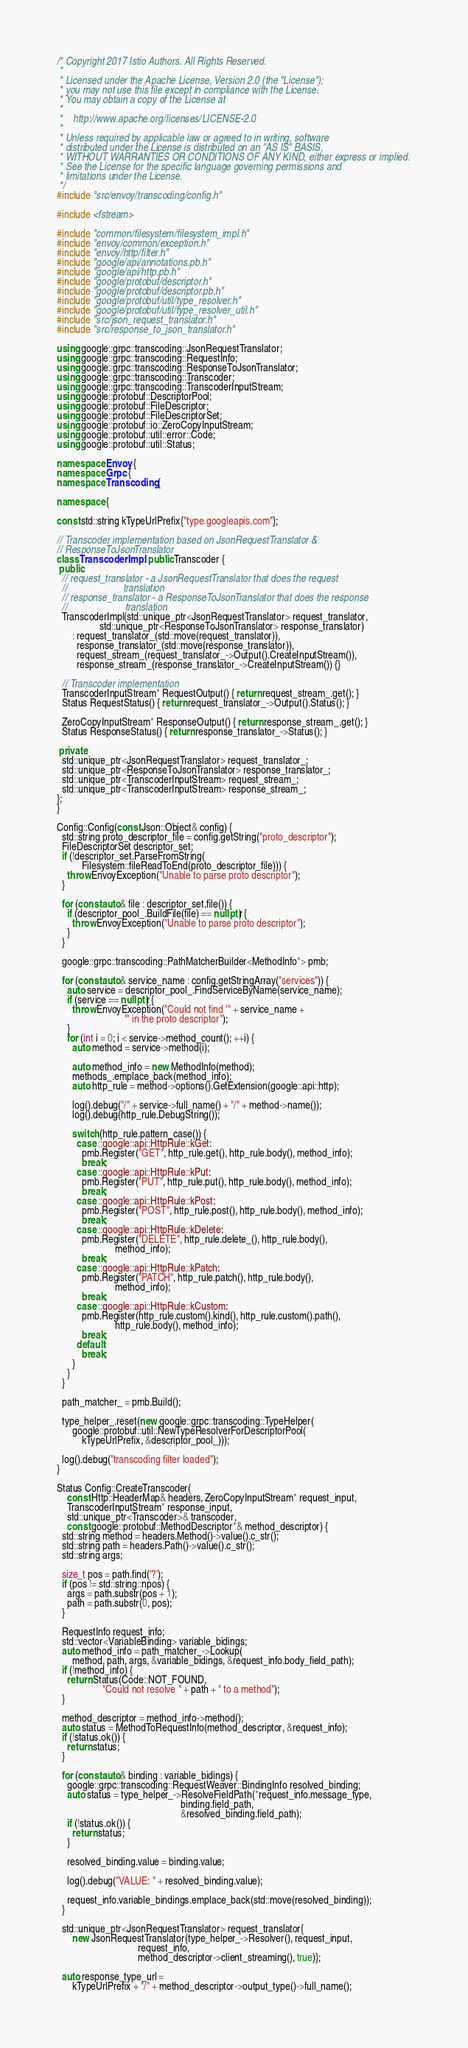<code> <loc_0><loc_0><loc_500><loc_500><_C++_>/* Copyright 2017 Istio Authors. All Rights Reserved.
 *
 * Licensed under the Apache License, Version 2.0 (the "License");
 * you may not use this file except in compliance with the License.
 * You may obtain a copy of the License at
 *
 *    http://www.apache.org/licenses/LICENSE-2.0
 *
 * Unless required by applicable law or agreed to in writing, software
 * distributed under the License is distributed on an "AS IS" BASIS,
 * WITHOUT WARRANTIES OR CONDITIONS OF ANY KIND, either express or implied.
 * See the License for the specific language governing permissions and
 * limitations under the License.
 */
#include "src/envoy/transcoding/config.h"

#include <fstream>

#include "common/filesystem/filesystem_impl.h"
#include "envoy/common/exception.h"
#include "envoy/http/filter.h"
#include "google/api/annotations.pb.h"
#include "google/api/http.pb.h"
#include "google/protobuf/descriptor.h"
#include "google/protobuf/descriptor.pb.h"
#include "google/protobuf/util/type_resolver.h"
#include "google/protobuf/util/type_resolver_util.h"
#include "src/json_request_translator.h"
#include "src/response_to_json_translator.h"

using google::grpc::transcoding::JsonRequestTranslator;
using google::grpc::transcoding::RequestInfo;
using google::grpc::transcoding::ResponseToJsonTranslator;
using google::grpc::transcoding::Transcoder;
using google::grpc::transcoding::TranscoderInputStream;
using google::protobuf::DescriptorPool;
using google::protobuf::FileDescriptor;
using google::protobuf::FileDescriptorSet;
using google::protobuf::io::ZeroCopyInputStream;
using google::protobuf::util::error::Code;
using google::protobuf::util::Status;

namespace Envoy {
namespace Grpc {
namespace Transcoding {

namespace {

const std::string kTypeUrlPrefix{"type.googleapis.com"};

// Transcoder implementation based on JsonRequestTranslator &
// ResponseToJsonTranslator
class TranscoderImpl : public Transcoder {
 public:
  // request_translator - a JsonRequestTranslator that does the request
  //                      translation
  // response_translator - a ResponseToJsonTranslator that does the response
  //                       translation
  TranscoderImpl(std::unique_ptr<JsonRequestTranslator> request_translator,
                 std::unique_ptr<ResponseToJsonTranslator> response_translator)
      : request_translator_(std::move(request_translator)),
        response_translator_(std::move(response_translator)),
        request_stream_(request_translator_->Output().CreateInputStream()),
        response_stream_(response_translator_->CreateInputStream()) {}

  // Transcoder implementation
  TranscoderInputStream* RequestOutput() { return request_stream_.get(); }
  Status RequestStatus() { return request_translator_->Output().Status(); }

  ZeroCopyInputStream* ResponseOutput() { return response_stream_.get(); }
  Status ResponseStatus() { return response_translator_->Status(); }

 private:
  std::unique_ptr<JsonRequestTranslator> request_translator_;
  std::unique_ptr<ResponseToJsonTranslator> response_translator_;
  std::unique_ptr<TranscoderInputStream> request_stream_;
  std::unique_ptr<TranscoderInputStream> response_stream_;
};
}

Config::Config(const Json::Object& config) {
  std::string proto_descriptor_file = config.getString("proto_descriptor");
  FileDescriptorSet descriptor_set;
  if (!descriptor_set.ParseFromString(
          Filesystem::fileReadToEnd(proto_descriptor_file))) {
    throw EnvoyException("Unable to parse proto descriptor");
  }

  for (const auto& file : descriptor_set.file()) {
    if (descriptor_pool_.BuildFile(file) == nullptr) {
      throw EnvoyException("Unable to parse proto descriptor");
    }
  }

  google::grpc::transcoding::PathMatcherBuilder<MethodInfo*> pmb;

  for (const auto& service_name : config.getStringArray("services")) {
    auto service = descriptor_pool_.FindServiceByName(service_name);
    if (service == nullptr) {
      throw EnvoyException("Could not find '" + service_name +
                           "' in the proto descriptor");
    }
    for (int i = 0; i < service->method_count(); ++i) {
      auto method = service->method(i);

      auto method_info = new MethodInfo(method);
      methods_.emplace_back(method_info);
      auto http_rule = method->options().GetExtension(google::api::http);

      log().debug("/" + service->full_name() + "/" + method->name());
      log().debug(http_rule.DebugString());

      switch (http_rule.pattern_case()) {
        case ::google::api::HttpRule::kGet:
          pmb.Register("GET", http_rule.get(), http_rule.body(), method_info);
          break;
        case ::google::api::HttpRule::kPut:
          pmb.Register("PUT", http_rule.put(), http_rule.body(), method_info);
          break;
        case ::google::api::HttpRule::kPost:
          pmb.Register("POST", http_rule.post(), http_rule.body(), method_info);
          break;
        case ::google::api::HttpRule::kDelete:
          pmb.Register("DELETE", http_rule.delete_(), http_rule.body(),
                       method_info);
          break;
        case ::google::api::HttpRule::kPatch:
          pmb.Register("PATCH", http_rule.patch(), http_rule.body(),
                       method_info);
          break;
        case ::google::api::HttpRule::kCustom:
          pmb.Register(http_rule.custom().kind(), http_rule.custom().path(),
                       http_rule.body(), method_info);
          break;
        default:
          break;
      }
    }
  }

  path_matcher_ = pmb.Build();

  type_helper_.reset(new google::grpc::transcoding::TypeHelper(
      google::protobuf::util::NewTypeResolverForDescriptorPool(
          kTypeUrlPrefix, &descriptor_pool_)));

  log().debug("transcoding filter loaded");
}

Status Config::CreateTranscoder(
    const Http::HeaderMap& headers, ZeroCopyInputStream* request_input,
    TranscoderInputStream* response_input,
    std::unique_ptr<Transcoder>& transcoder,
    const google::protobuf::MethodDescriptor*& method_descriptor) {
  std::string method = headers.Method()->value().c_str();
  std::string path = headers.Path()->value().c_str();
  std::string args;

  size_t pos = path.find('?');
  if (pos != std::string::npos) {
    args = path.substr(pos + 1);
    path = path.substr(0, pos);
  }

  RequestInfo request_info;
  std::vector<VariableBinding> variable_bidings;
  auto method_info = path_matcher_->Lookup(
      method, path, args, &variable_bidings, &request_info.body_field_path);
  if (!method_info) {
    return Status(Code::NOT_FOUND,
                  "Could not resolve " + path + " to a method");
  }

  method_descriptor = method_info->method();
  auto status = MethodToRequestInfo(method_descriptor, &request_info);
  if (!status.ok()) {
    return status;
  }

  for (const auto& binding : variable_bidings) {
    google::grpc::transcoding::RequestWeaver::BindingInfo resolved_binding;
    auto status = type_helper_->ResolveFieldPath(*request_info.message_type,
                                                 binding.field_path,
                                                 &resolved_binding.field_path);
    if (!status.ok()) {
      return status;
    }

    resolved_binding.value = binding.value;

    log().debug("VALUE: " + resolved_binding.value);

    request_info.variable_bindings.emplace_back(std::move(resolved_binding));
  }

  std::unique_ptr<JsonRequestTranslator> request_translator{
      new JsonRequestTranslator(type_helper_->Resolver(), request_input,
                                request_info,
                                method_descriptor->client_streaming(), true)};

  auto response_type_url =
      kTypeUrlPrefix + "/" + method_descriptor->output_type()->full_name();</code> 